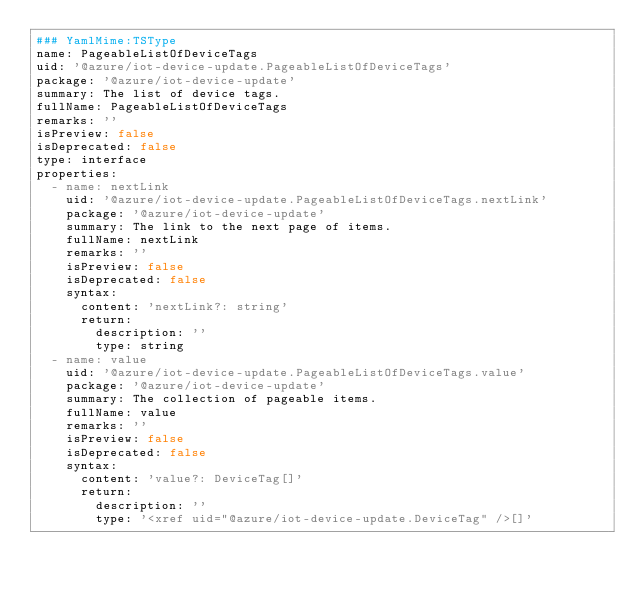<code> <loc_0><loc_0><loc_500><loc_500><_YAML_>### YamlMime:TSType
name: PageableListOfDeviceTags
uid: '@azure/iot-device-update.PageableListOfDeviceTags'
package: '@azure/iot-device-update'
summary: The list of device tags.
fullName: PageableListOfDeviceTags
remarks: ''
isPreview: false
isDeprecated: false
type: interface
properties:
  - name: nextLink
    uid: '@azure/iot-device-update.PageableListOfDeviceTags.nextLink'
    package: '@azure/iot-device-update'
    summary: The link to the next page of items.
    fullName: nextLink
    remarks: ''
    isPreview: false
    isDeprecated: false
    syntax:
      content: 'nextLink?: string'
      return:
        description: ''
        type: string
  - name: value
    uid: '@azure/iot-device-update.PageableListOfDeviceTags.value'
    package: '@azure/iot-device-update'
    summary: The collection of pageable items.
    fullName: value
    remarks: ''
    isPreview: false
    isDeprecated: false
    syntax:
      content: 'value?: DeviceTag[]'
      return:
        description: ''
        type: '<xref uid="@azure/iot-device-update.DeviceTag" />[]'
</code> 